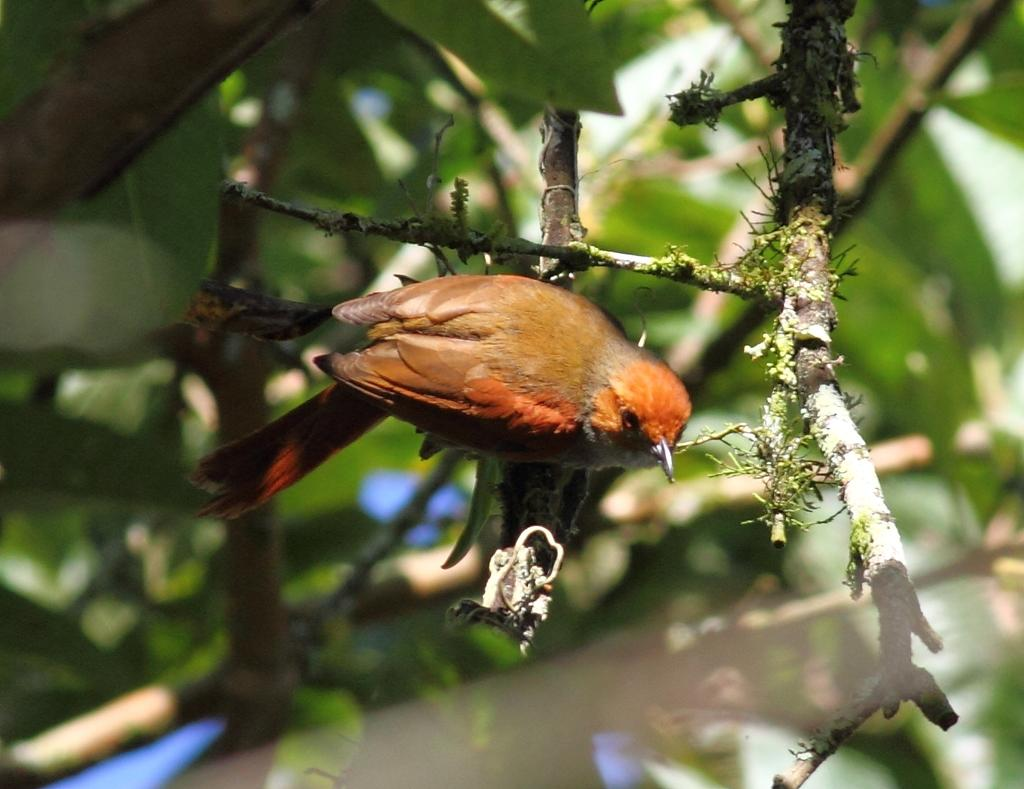What type of animal can be seen in the image? There is a bird in the image. Where is the bird located? The bird is on a tree. What colors can be observed on the bird? The bird has orange and brown colors. What is the color of the tree in the background? The tree in the background has a green color. What is the color of the sky in the background? The sky in the background has a white color. Can you see the kitty playing with the bird in the image? There is no kitty present in the image, and the bird is on a tree, not playing with any other animals. 